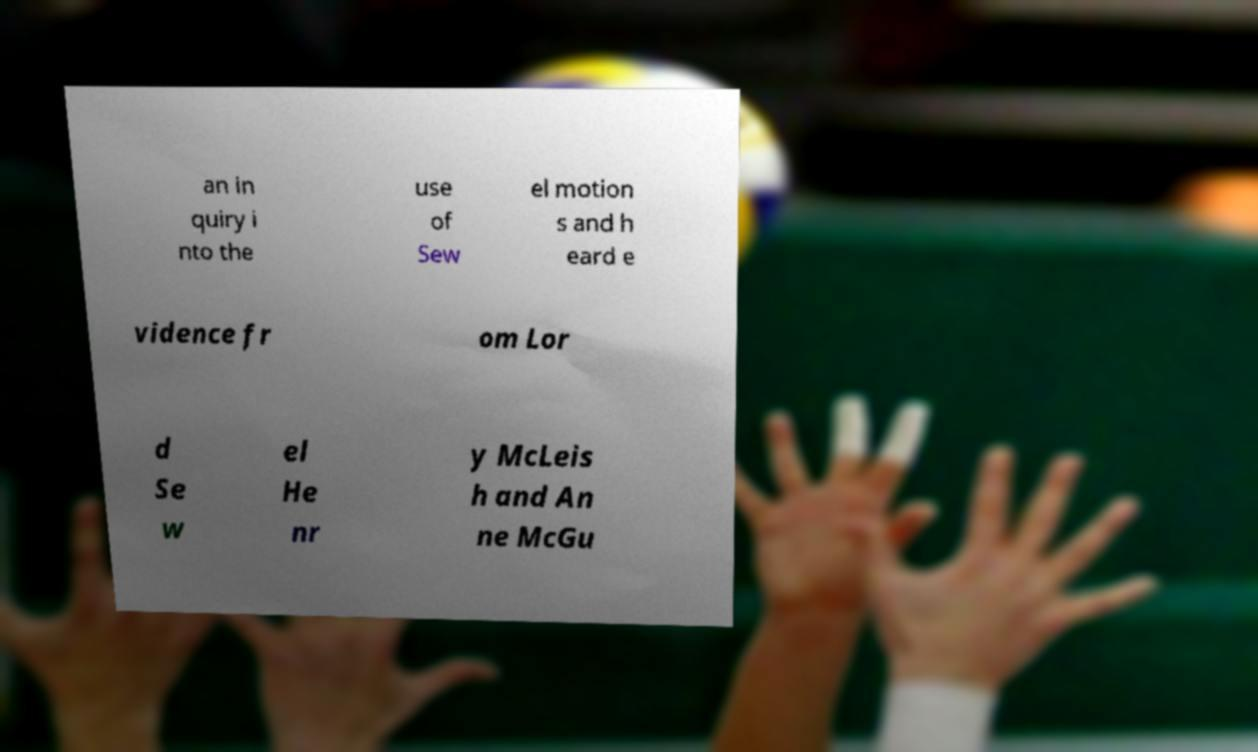For documentation purposes, I need the text within this image transcribed. Could you provide that? an in quiry i nto the use of Sew el motion s and h eard e vidence fr om Lor d Se w el He nr y McLeis h and An ne McGu 